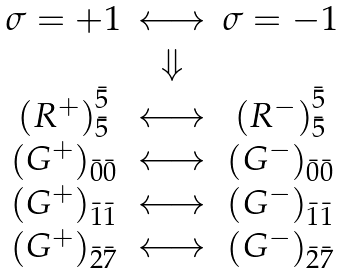Convert formula to latex. <formula><loc_0><loc_0><loc_500><loc_500>\begin{array} { c c c } \sigma = + 1 & \longleftrightarrow & \sigma = - 1 \\ & \Downarrow & \\ \left ( R ^ { + } \right ) ^ { \bar { 5 } } _ { \bar { 5 } } & \longleftrightarrow & \left ( R ^ { - } \right ) ^ { \bar { 5 } } _ { \bar { 5 } } \\ \left ( G ^ { + } \right ) _ { \bar { 0 } \bar { 0 } } & \longleftrightarrow & \left ( G ^ { - } \right ) _ { \bar { 0 } \bar { 0 } } \\ \left ( G ^ { + } \right ) _ { \bar { 1 } \bar { 1 } } & \longleftrightarrow & \left ( G ^ { - } \right ) _ { \bar { 1 } \bar { 1 } } \\ \left ( G ^ { + } \right ) _ { \bar { 2 } \bar { 7 } } & \longleftrightarrow & \left ( G ^ { - } \right ) _ { \bar { 2 } \bar { 7 } } \end{array}</formula> 